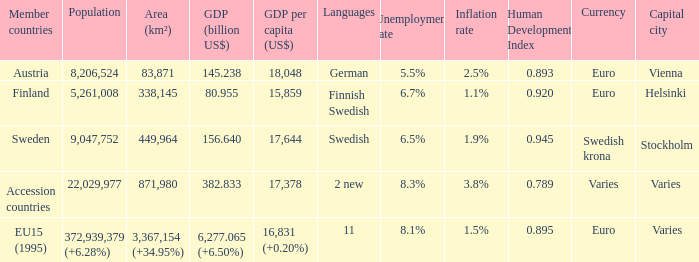Name the population for 11 languages 372,939,379 (+6.28%). 